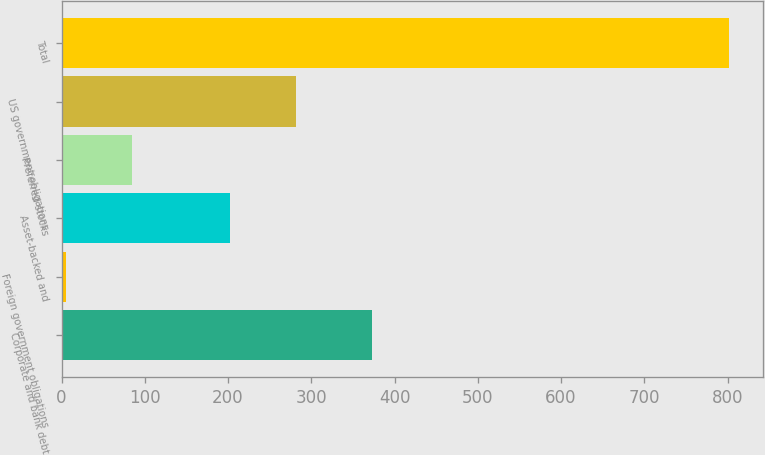Convert chart. <chart><loc_0><loc_0><loc_500><loc_500><bar_chart><fcel>Corporate and bank debt<fcel>Foreign government obligations<fcel>Asset-backed and<fcel>Preferred stocks<fcel>US government obligations<fcel>Total<nl><fcel>373<fcel>5<fcel>202<fcel>84.7<fcel>281.7<fcel>802<nl></chart> 